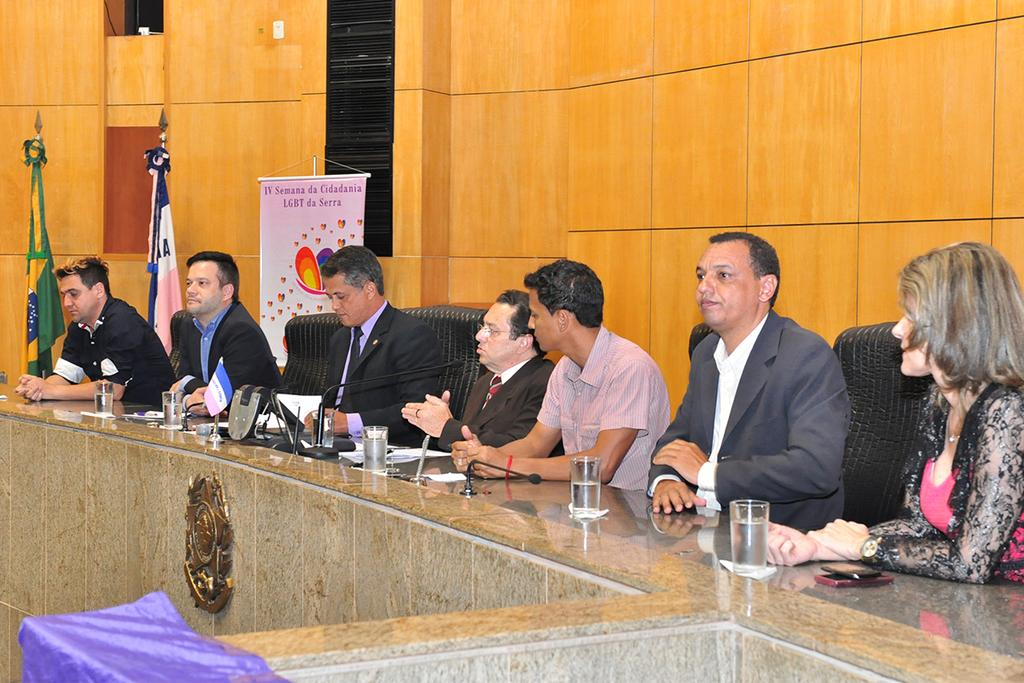What are the people in the image doing? The people in the image are sitting on chairs. What objects can be seen on a surface in the image? Water glasses are visible on a surface in the image. What device is present in the image that is used for amplifying sound? A microphone is present in the image. What type of signage is visible in the image? There is a banner in the image. What type of tail can be seen on the dad in the image? There is no dad present in the image, and therefore no tail can be seen. 